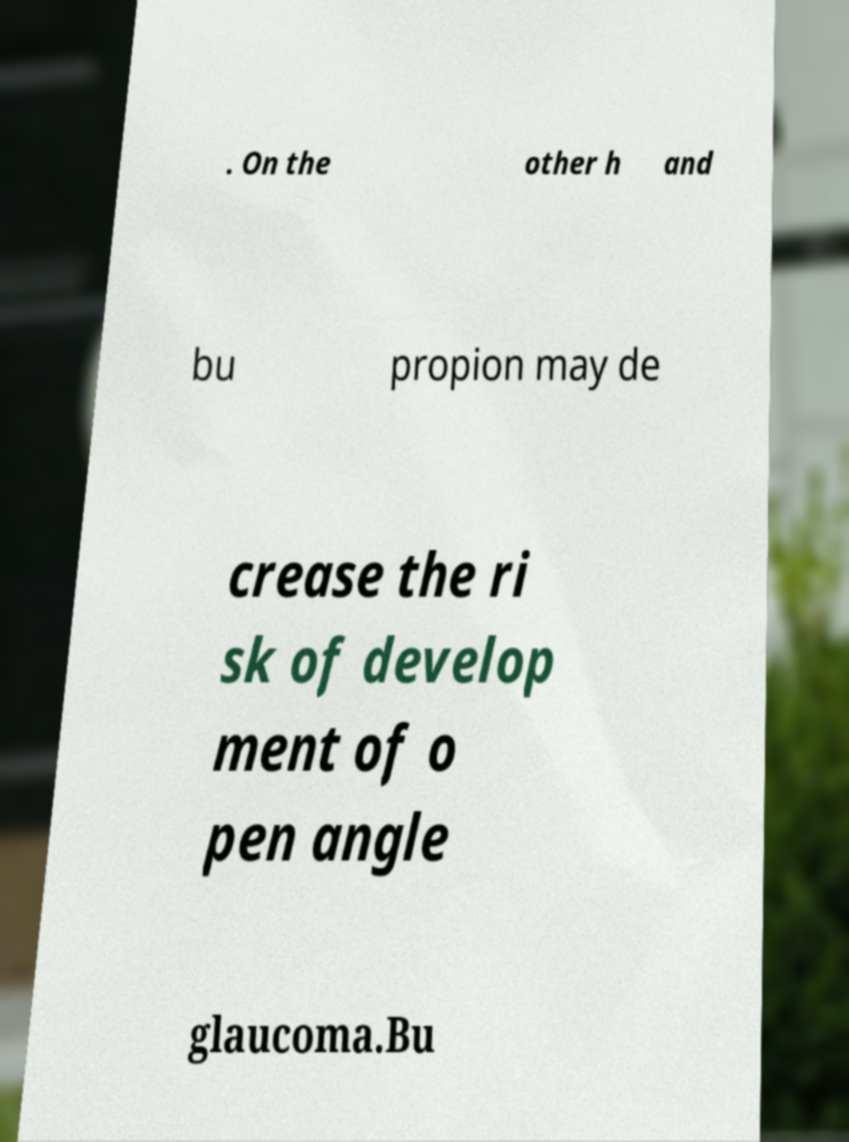What messages or text are displayed in this image? I need them in a readable, typed format. . On the other h and bu propion may de crease the ri sk of develop ment of o pen angle glaucoma.Bu 